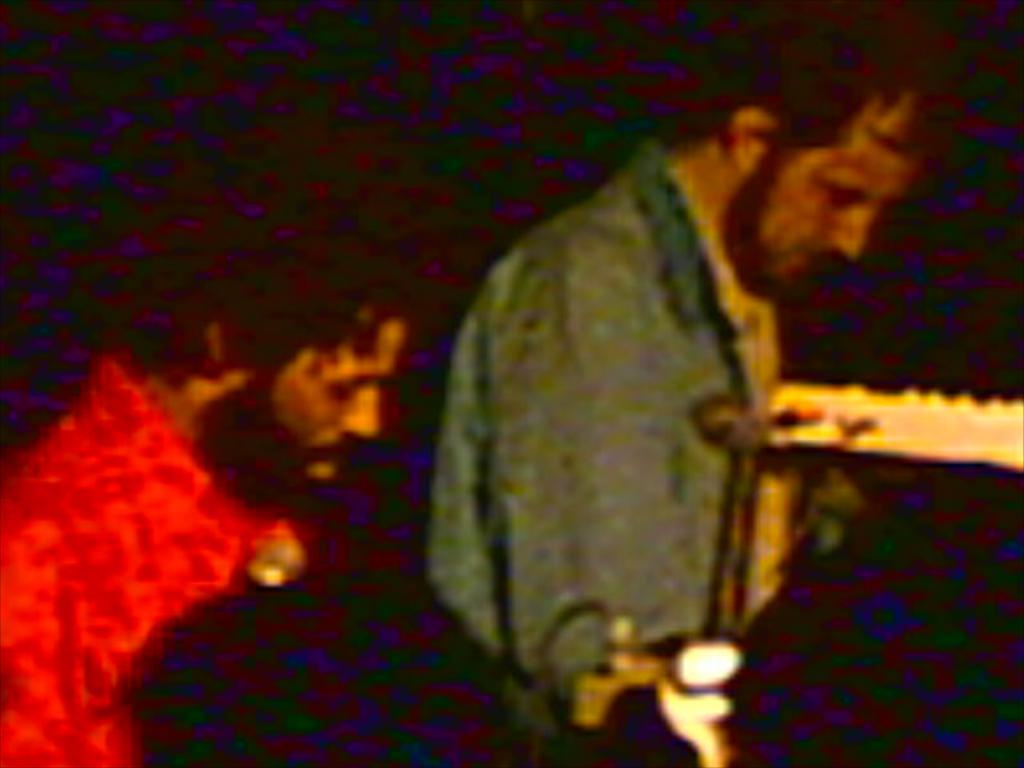How many people are in the image? There are two persons in the image. What can be observed about the background of the image? The background of the image is dark. How many women are on stage in the image? There is no stage or women present in the image; it features two persons in a dark background. 